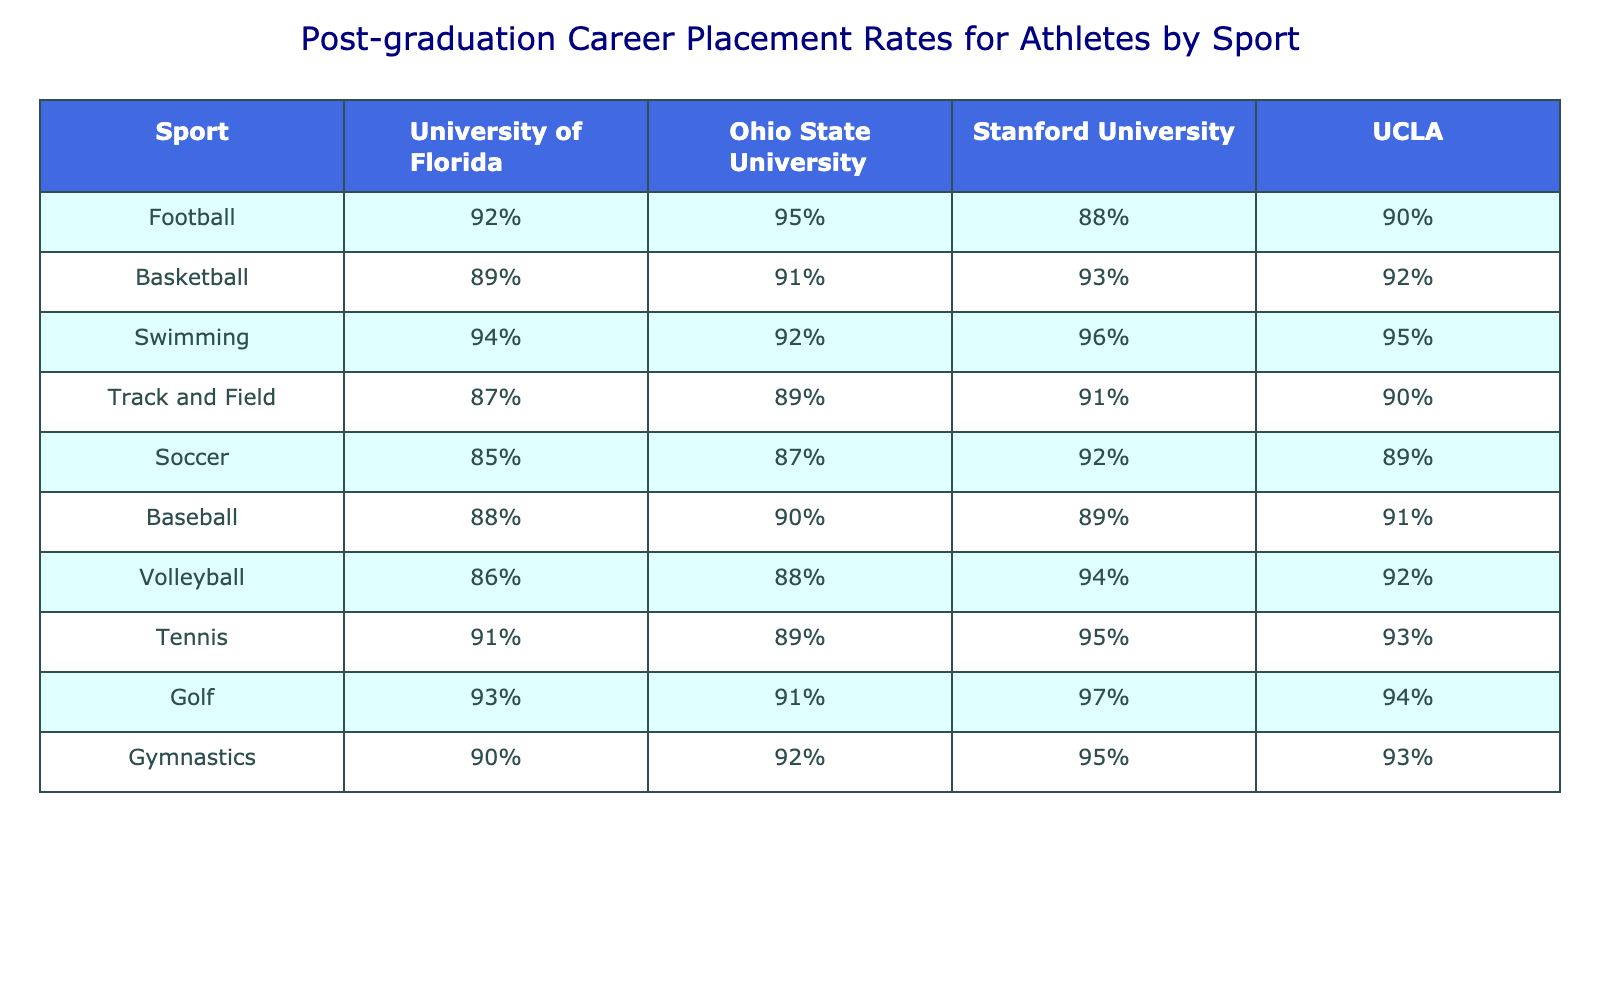What is the post-graduation career placement rate for athletes in football at Ohio State University? According to the table, the post-graduation career placement rate for football athletes at Ohio State University is 95%.
Answer: 95% Which university has the highest placement rate for swimming athletes? The table shows Stanford University has the highest post-graduation placement rate for swimming athletes at 96%.
Answer: Stanford University What is the difference in placement rates for basketball athletes between Stanford University and UCLA? The placement rate for basketball at Stanford University is 93%, while at UCLA it is 92%. The difference is 93% - 92% = 1%.
Answer: 1% True or False: The placement rate for soccer athletes at the University of Florida is higher than that at Ohio State University. Looking at the table, the soccer placement rate for the University of Florida is 85%, while for Ohio State University it is 87%. Thus, the statement is false.
Answer: False What is the average post-graduation placement rate for tennis athletes across all universities listed? To find the average, add the placement rates for tennis: (91% + 89% + 95% + 93%) = 368%. There are 4 universities, so the average is 368% / 4 = 92%.
Answer: 92% Which sport has the lowest placement rate at UCLA? Upon reviewing the table, soccer has the lowest placement rate at UCLA, which is 89%.
Answer: Soccer If you combine the placement rates for volleyball athletes at Ohio State University and Stanford University, what is the total? The volleyball placement rate at Ohio State University is 88%, and at Stanford it is 94%. Adding them gives 88% + 94% = 182%.
Answer: 182% How does the placement rate for baseball athletes at the University of Florida compare to that at UCLA? The baseball placement rate at the University of Florida is 88%, while at UCLA it is 91%. Therefore, the rate at UCLA is 3% higher than at the University of Florida.
Answer: 3% higher Which university has better overall placement rates for track and field athletes: Ohio State University or UCLA? From the table, Ohio State University has a track and field placement rate of 89%, while UCLA has 90%. Thus, UCLA has a slightly better rate.
Answer: UCLA Is the placement rate for golf athletes at the University of Florida higher than the average placement rate for all sports at Stanford University? The placement rate for golf athletes at the University of Florida is 93%. To find the average for all sports at Stanford, calculate: (88% + 93% + 96% + 91% + 92% + 89% + 94% + 95% + 97% + 95%)/10 = 93.6%. Since 93% is less than 93.6%, the answer is no.
Answer: No 